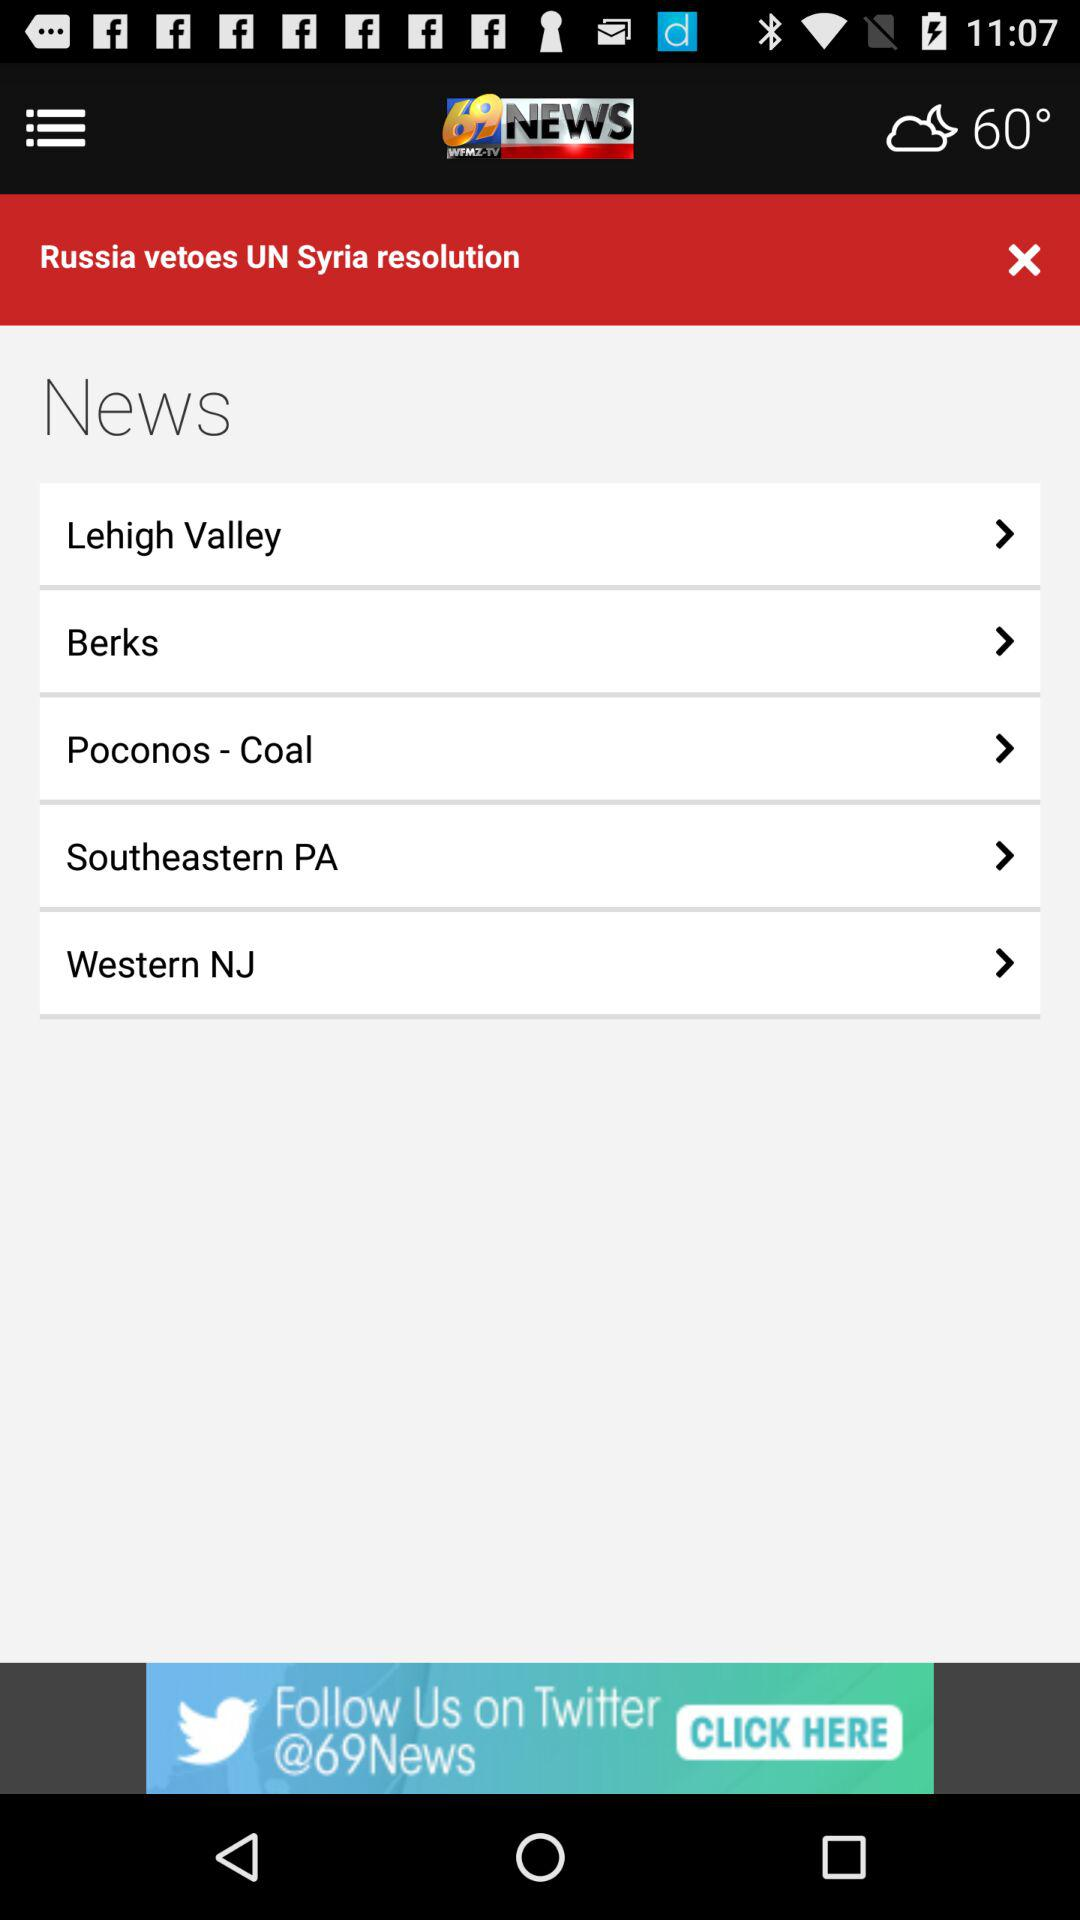What is the current temperature? The current temperature is 60 degrees. 